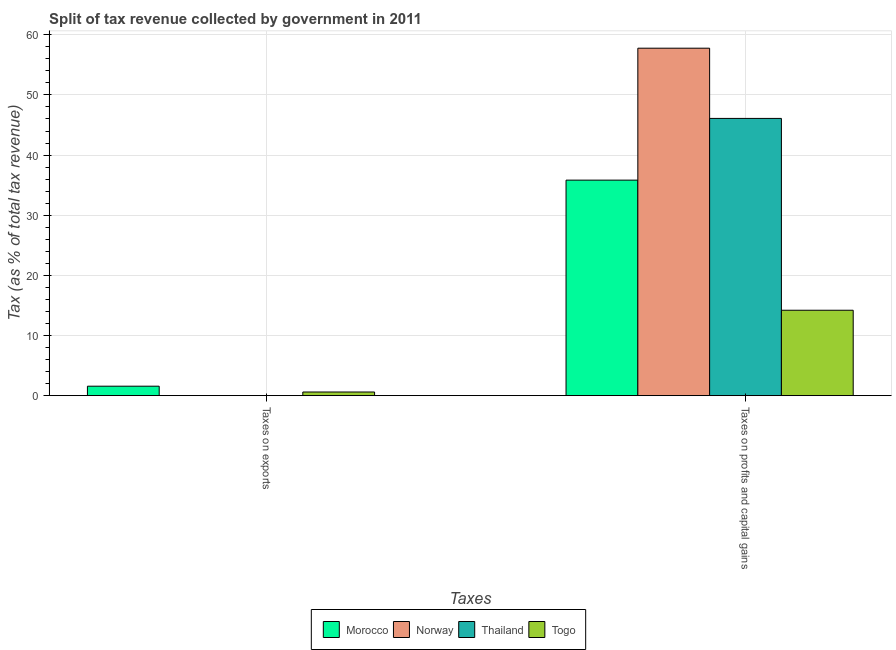How many different coloured bars are there?
Your response must be concise. 4. What is the label of the 2nd group of bars from the left?
Keep it short and to the point. Taxes on profits and capital gains. What is the percentage of revenue obtained from taxes on exports in Togo?
Your response must be concise. 0.6. Across all countries, what is the maximum percentage of revenue obtained from taxes on exports?
Your answer should be very brief. 1.57. Across all countries, what is the minimum percentage of revenue obtained from taxes on profits and capital gains?
Provide a short and direct response. 14.2. In which country was the percentage of revenue obtained from taxes on exports minimum?
Offer a very short reply. Thailand. What is the total percentage of revenue obtained from taxes on profits and capital gains in the graph?
Your response must be concise. 153.89. What is the difference between the percentage of revenue obtained from taxes on profits and capital gains in Morocco and that in Togo?
Offer a very short reply. 21.63. What is the difference between the percentage of revenue obtained from taxes on profits and capital gains in Togo and the percentage of revenue obtained from taxes on exports in Morocco?
Make the answer very short. 12.63. What is the average percentage of revenue obtained from taxes on profits and capital gains per country?
Offer a very short reply. 38.47. What is the difference between the percentage of revenue obtained from taxes on exports and percentage of revenue obtained from taxes on profits and capital gains in Morocco?
Provide a short and direct response. -34.26. In how many countries, is the percentage of revenue obtained from taxes on profits and capital gains greater than 22 %?
Your answer should be very brief. 3. What is the ratio of the percentage of revenue obtained from taxes on profits and capital gains in Norway to that in Togo?
Provide a short and direct response. 4.07. Is the percentage of revenue obtained from taxes on profits and capital gains in Togo less than that in Norway?
Your answer should be very brief. Yes. In how many countries, is the percentage of revenue obtained from taxes on profits and capital gains greater than the average percentage of revenue obtained from taxes on profits and capital gains taken over all countries?
Give a very brief answer. 2. What does the 4th bar from the left in Taxes on profits and capital gains represents?
Your answer should be compact. Togo. What does the 1st bar from the right in Taxes on profits and capital gains represents?
Your response must be concise. Togo. Are all the bars in the graph horizontal?
Your response must be concise. No. How many countries are there in the graph?
Offer a very short reply. 4. What is the difference between two consecutive major ticks on the Y-axis?
Your response must be concise. 10. Does the graph contain grids?
Your answer should be very brief. Yes. Where does the legend appear in the graph?
Keep it short and to the point. Bottom center. What is the title of the graph?
Keep it short and to the point. Split of tax revenue collected by government in 2011. What is the label or title of the X-axis?
Your answer should be very brief. Taxes. What is the label or title of the Y-axis?
Ensure brevity in your answer.  Tax (as % of total tax revenue). What is the Tax (as % of total tax revenue) in Morocco in Taxes on exports?
Make the answer very short. 1.57. What is the Tax (as % of total tax revenue) of Norway in Taxes on exports?
Give a very brief answer. 0.02. What is the Tax (as % of total tax revenue) in Thailand in Taxes on exports?
Your answer should be very brief. 0.01. What is the Tax (as % of total tax revenue) of Togo in Taxes on exports?
Your response must be concise. 0.6. What is the Tax (as % of total tax revenue) of Morocco in Taxes on profits and capital gains?
Ensure brevity in your answer.  35.83. What is the Tax (as % of total tax revenue) in Norway in Taxes on profits and capital gains?
Keep it short and to the point. 57.77. What is the Tax (as % of total tax revenue) of Thailand in Taxes on profits and capital gains?
Provide a short and direct response. 46.09. What is the Tax (as % of total tax revenue) in Togo in Taxes on profits and capital gains?
Provide a short and direct response. 14.2. Across all Taxes, what is the maximum Tax (as % of total tax revenue) of Morocco?
Ensure brevity in your answer.  35.83. Across all Taxes, what is the maximum Tax (as % of total tax revenue) in Norway?
Give a very brief answer. 57.77. Across all Taxes, what is the maximum Tax (as % of total tax revenue) of Thailand?
Your answer should be compact. 46.09. Across all Taxes, what is the maximum Tax (as % of total tax revenue) of Togo?
Provide a short and direct response. 14.2. Across all Taxes, what is the minimum Tax (as % of total tax revenue) of Morocco?
Give a very brief answer. 1.57. Across all Taxes, what is the minimum Tax (as % of total tax revenue) in Norway?
Your answer should be very brief. 0.02. Across all Taxes, what is the minimum Tax (as % of total tax revenue) in Thailand?
Your answer should be compact. 0.01. Across all Taxes, what is the minimum Tax (as % of total tax revenue) of Togo?
Provide a succinct answer. 0.6. What is the total Tax (as % of total tax revenue) of Morocco in the graph?
Your response must be concise. 37.4. What is the total Tax (as % of total tax revenue) of Norway in the graph?
Make the answer very short. 57.79. What is the total Tax (as % of total tax revenue) of Thailand in the graph?
Your response must be concise. 46.11. What is the total Tax (as % of total tax revenue) in Togo in the graph?
Your answer should be very brief. 14.8. What is the difference between the Tax (as % of total tax revenue) of Morocco in Taxes on exports and that in Taxes on profits and capital gains?
Your response must be concise. -34.26. What is the difference between the Tax (as % of total tax revenue) in Norway in Taxes on exports and that in Taxes on profits and capital gains?
Your response must be concise. -57.75. What is the difference between the Tax (as % of total tax revenue) of Thailand in Taxes on exports and that in Taxes on profits and capital gains?
Ensure brevity in your answer.  -46.08. What is the difference between the Tax (as % of total tax revenue) in Togo in Taxes on exports and that in Taxes on profits and capital gains?
Offer a terse response. -13.59. What is the difference between the Tax (as % of total tax revenue) of Morocco in Taxes on exports and the Tax (as % of total tax revenue) of Norway in Taxes on profits and capital gains?
Offer a terse response. -56.2. What is the difference between the Tax (as % of total tax revenue) in Morocco in Taxes on exports and the Tax (as % of total tax revenue) in Thailand in Taxes on profits and capital gains?
Keep it short and to the point. -44.52. What is the difference between the Tax (as % of total tax revenue) in Morocco in Taxes on exports and the Tax (as % of total tax revenue) in Togo in Taxes on profits and capital gains?
Give a very brief answer. -12.63. What is the difference between the Tax (as % of total tax revenue) in Norway in Taxes on exports and the Tax (as % of total tax revenue) in Thailand in Taxes on profits and capital gains?
Give a very brief answer. -46.07. What is the difference between the Tax (as % of total tax revenue) in Norway in Taxes on exports and the Tax (as % of total tax revenue) in Togo in Taxes on profits and capital gains?
Your response must be concise. -14.18. What is the difference between the Tax (as % of total tax revenue) of Thailand in Taxes on exports and the Tax (as % of total tax revenue) of Togo in Taxes on profits and capital gains?
Your response must be concise. -14.19. What is the average Tax (as % of total tax revenue) of Morocco per Taxes?
Your response must be concise. 18.7. What is the average Tax (as % of total tax revenue) of Norway per Taxes?
Offer a terse response. 28.9. What is the average Tax (as % of total tax revenue) of Thailand per Taxes?
Provide a short and direct response. 23.05. What is the average Tax (as % of total tax revenue) of Togo per Taxes?
Make the answer very short. 7.4. What is the difference between the Tax (as % of total tax revenue) of Morocco and Tax (as % of total tax revenue) of Norway in Taxes on exports?
Your answer should be very brief. 1.55. What is the difference between the Tax (as % of total tax revenue) in Morocco and Tax (as % of total tax revenue) in Thailand in Taxes on exports?
Your answer should be very brief. 1.56. What is the difference between the Tax (as % of total tax revenue) in Morocco and Tax (as % of total tax revenue) in Togo in Taxes on exports?
Offer a terse response. 0.97. What is the difference between the Tax (as % of total tax revenue) in Norway and Tax (as % of total tax revenue) in Thailand in Taxes on exports?
Your response must be concise. 0.01. What is the difference between the Tax (as % of total tax revenue) of Norway and Tax (as % of total tax revenue) of Togo in Taxes on exports?
Offer a very short reply. -0.58. What is the difference between the Tax (as % of total tax revenue) in Thailand and Tax (as % of total tax revenue) in Togo in Taxes on exports?
Keep it short and to the point. -0.59. What is the difference between the Tax (as % of total tax revenue) of Morocco and Tax (as % of total tax revenue) of Norway in Taxes on profits and capital gains?
Offer a very short reply. -21.93. What is the difference between the Tax (as % of total tax revenue) of Morocco and Tax (as % of total tax revenue) of Thailand in Taxes on profits and capital gains?
Offer a terse response. -10.26. What is the difference between the Tax (as % of total tax revenue) of Morocco and Tax (as % of total tax revenue) of Togo in Taxes on profits and capital gains?
Provide a short and direct response. 21.63. What is the difference between the Tax (as % of total tax revenue) in Norway and Tax (as % of total tax revenue) in Thailand in Taxes on profits and capital gains?
Ensure brevity in your answer.  11.67. What is the difference between the Tax (as % of total tax revenue) in Norway and Tax (as % of total tax revenue) in Togo in Taxes on profits and capital gains?
Provide a short and direct response. 43.57. What is the difference between the Tax (as % of total tax revenue) of Thailand and Tax (as % of total tax revenue) of Togo in Taxes on profits and capital gains?
Provide a short and direct response. 31.9. What is the ratio of the Tax (as % of total tax revenue) of Morocco in Taxes on exports to that in Taxes on profits and capital gains?
Give a very brief answer. 0.04. What is the ratio of the Tax (as % of total tax revenue) of Norway in Taxes on exports to that in Taxes on profits and capital gains?
Keep it short and to the point. 0. What is the ratio of the Tax (as % of total tax revenue) in Togo in Taxes on exports to that in Taxes on profits and capital gains?
Offer a terse response. 0.04. What is the difference between the highest and the second highest Tax (as % of total tax revenue) in Morocco?
Give a very brief answer. 34.26. What is the difference between the highest and the second highest Tax (as % of total tax revenue) of Norway?
Your answer should be compact. 57.75. What is the difference between the highest and the second highest Tax (as % of total tax revenue) of Thailand?
Provide a succinct answer. 46.08. What is the difference between the highest and the second highest Tax (as % of total tax revenue) of Togo?
Offer a very short reply. 13.59. What is the difference between the highest and the lowest Tax (as % of total tax revenue) of Morocco?
Offer a terse response. 34.26. What is the difference between the highest and the lowest Tax (as % of total tax revenue) of Norway?
Keep it short and to the point. 57.75. What is the difference between the highest and the lowest Tax (as % of total tax revenue) of Thailand?
Give a very brief answer. 46.08. What is the difference between the highest and the lowest Tax (as % of total tax revenue) of Togo?
Give a very brief answer. 13.59. 